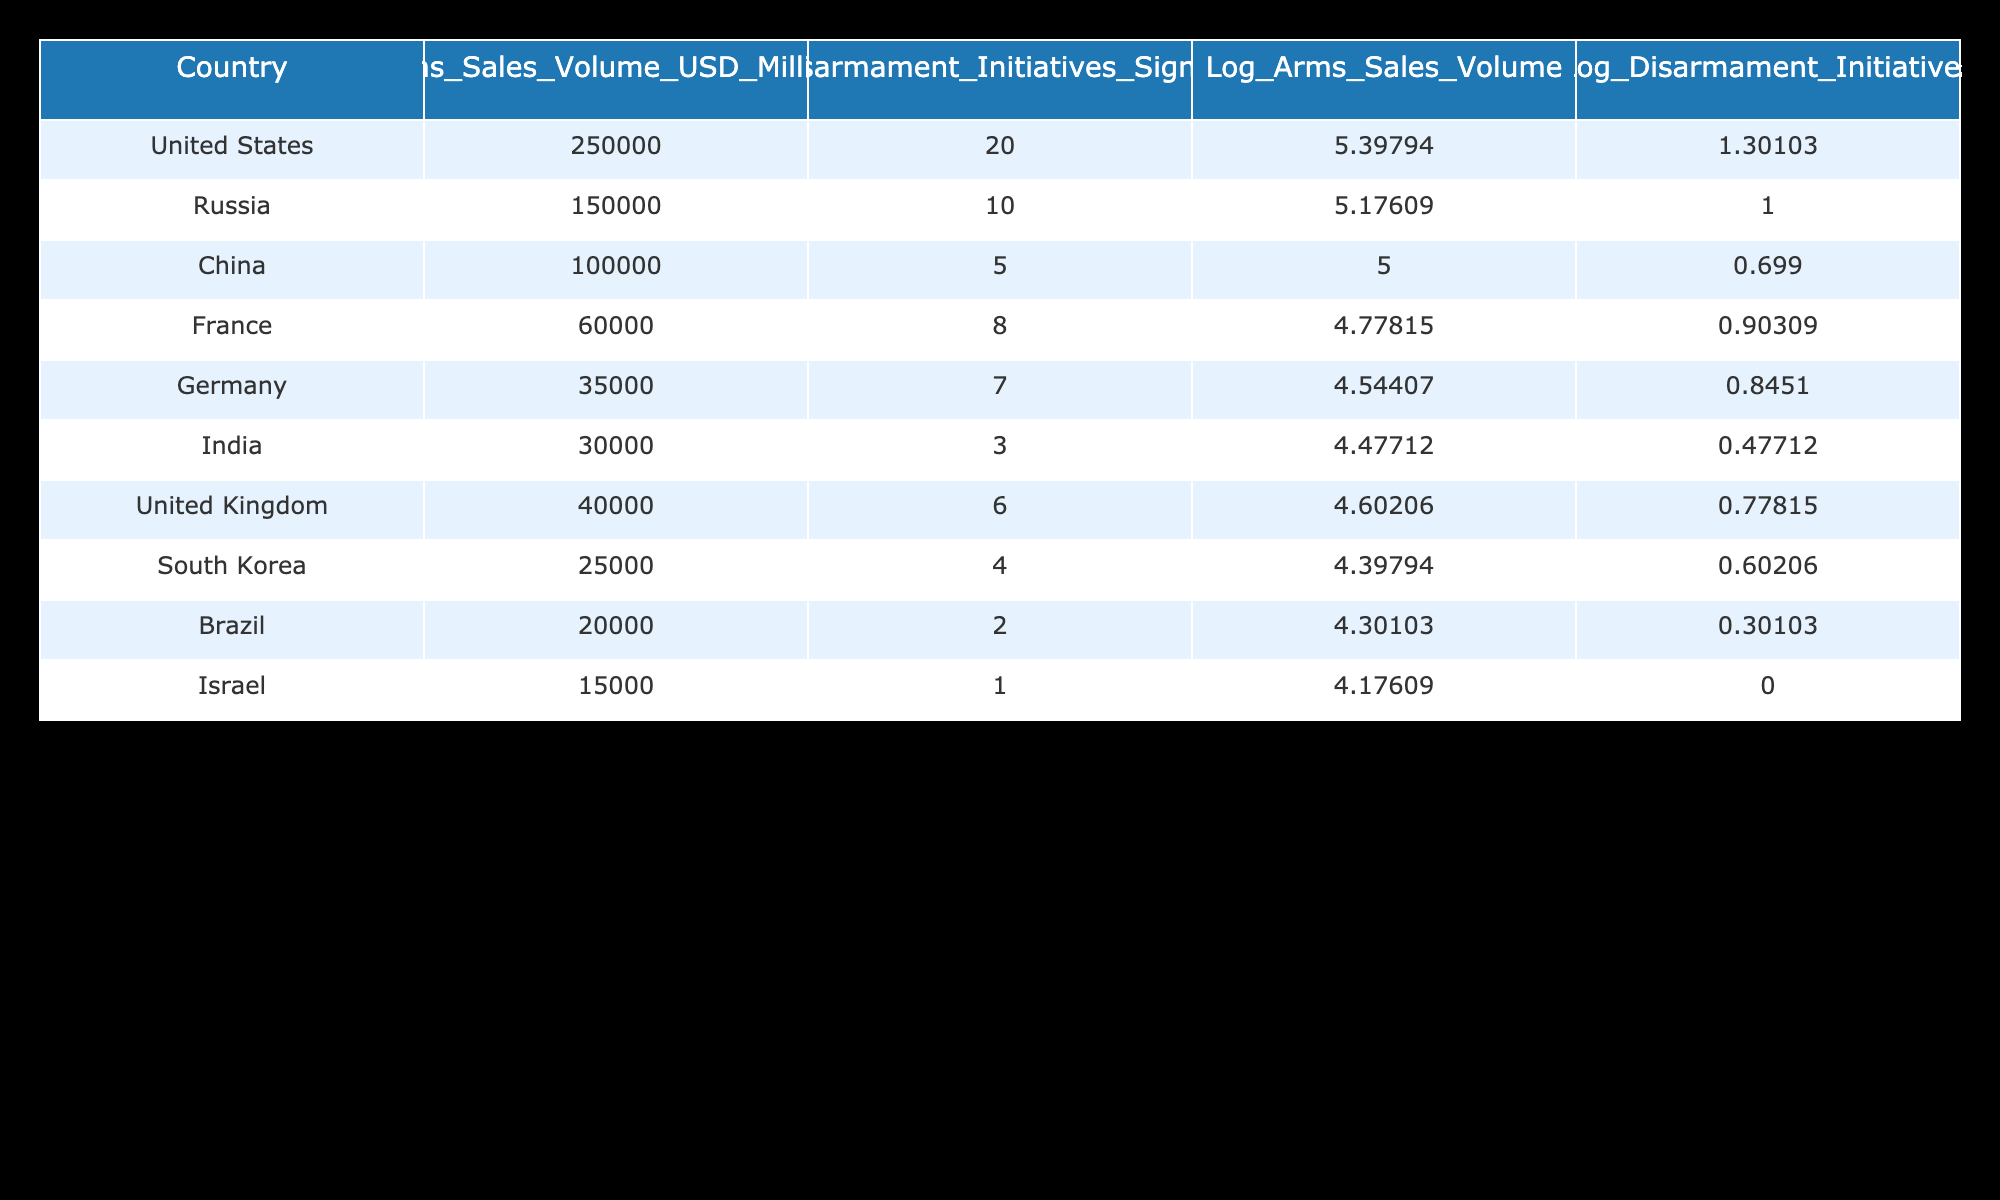What is the arms sales volume of the United States? The arms sales volume of the United States is directly listed in the table under the "Arms_Sales_Volume_USD_Millions" column, which shows 250,000 million USD.
Answer: 250,000 million USD Which country has the highest number of disarmament initiatives signed? By referring to the column "Disarmament_Initiatives_Signed", the United States has signed 20 initiatives, which is the highest compared to other countries in the table.
Answer: United States What is the sum of arms sales volumes for Russia and China? The arms sales volume for Russia is 150,000 million USD and for China is 100,000 million USD. Adding these gives 150,000 + 100,000 = 250,000 million USD.
Answer: 250,000 million USD Is it true that Israel has more disarmament initiatives signed than South Korea? Israel has signed 1 disarmament initiative, while South Korea has signed 4. Since 1 is less than 4, the statement is false.
Answer: No Which country has the lowest arms sales volume? The lowest arms sales volume can be found by checking the "Arms_Sales_Volume_USD_Millions" column for the smallest value, which is 15,000 million USD for Israel.
Answer: Israel What is the difference in disarmament initiatives signed between the United States and France? The United States has signed 20 initiatives, while France has signed 8. The difference is calculated as 20 - 8 = 12 initiatives.
Answer: 12 initiatives What is the average arms sales volume of the top three countries by arms sales volume? The top three countries by arms sales volume are the United States (250,000 million), Russia (150,000 million), and China (100,000 million). The average is (250,000 + 150,000 + 100,000) / 3 = 166,667 million USD.
Answer: 166,667 million USD Is the log of disarmament initiatives signed for Germany greater than that for India? The log of disarmament initiatives for Germany is 0.84510 and for India it is 0.47712. Since 0.84510 is greater than 0.47712, the statement is true.
Answer: Yes Which two countries have similar arms sales volumes, and what are those volumes? South Korea (25,000 million) and Brazil (20,000 million) have similar arms sales volumes close together, but the numbers are not too similar; however, they are the closest in range when looking at the data.
Answer: South Korea (25,000 million), Brazil (20,000 million) 